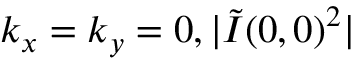<formula> <loc_0><loc_0><loc_500><loc_500>k _ { x } = k _ { y } = 0 , | \tilde { I } ( 0 , 0 ) ^ { 2 } |</formula> 